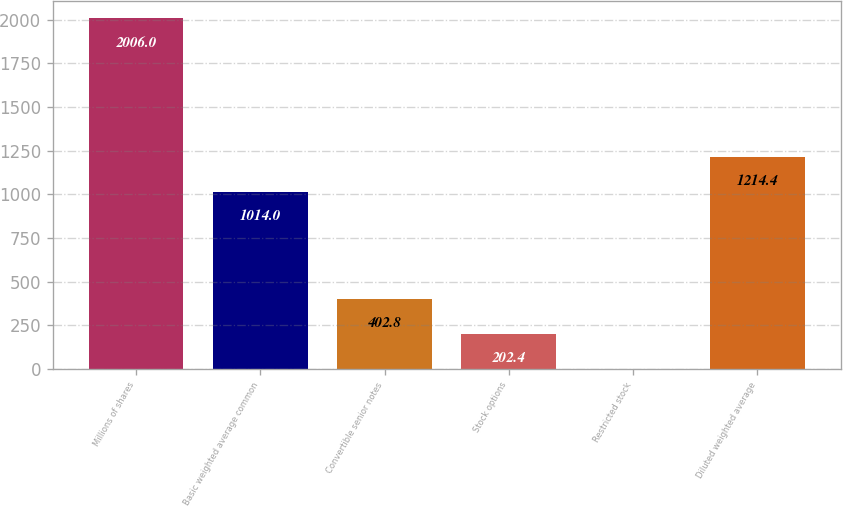Convert chart. <chart><loc_0><loc_0><loc_500><loc_500><bar_chart><fcel>Millions of shares<fcel>Basic weighted average common<fcel>Convertible senior notes<fcel>Stock options<fcel>Restricted stock<fcel>Diluted weighted average<nl><fcel>2006<fcel>1014<fcel>402.8<fcel>202.4<fcel>2<fcel>1214.4<nl></chart> 